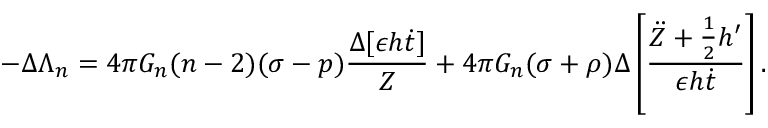Convert formula to latex. <formula><loc_0><loc_0><loc_500><loc_500>- \Delta \Lambda _ { n } = 4 \pi G _ { n } ( n - 2 ) ( \sigma - p ) \frac { \Delta [ \epsilon h \dot { t } ] } { Z } + 4 \pi G _ { n } ( \sigma + \rho ) \Delta \left [ \frac { \ddot { Z } + \frac { 1 } { 2 } h ^ { \prime } } { \epsilon h \dot { t } } \right ] .</formula> 